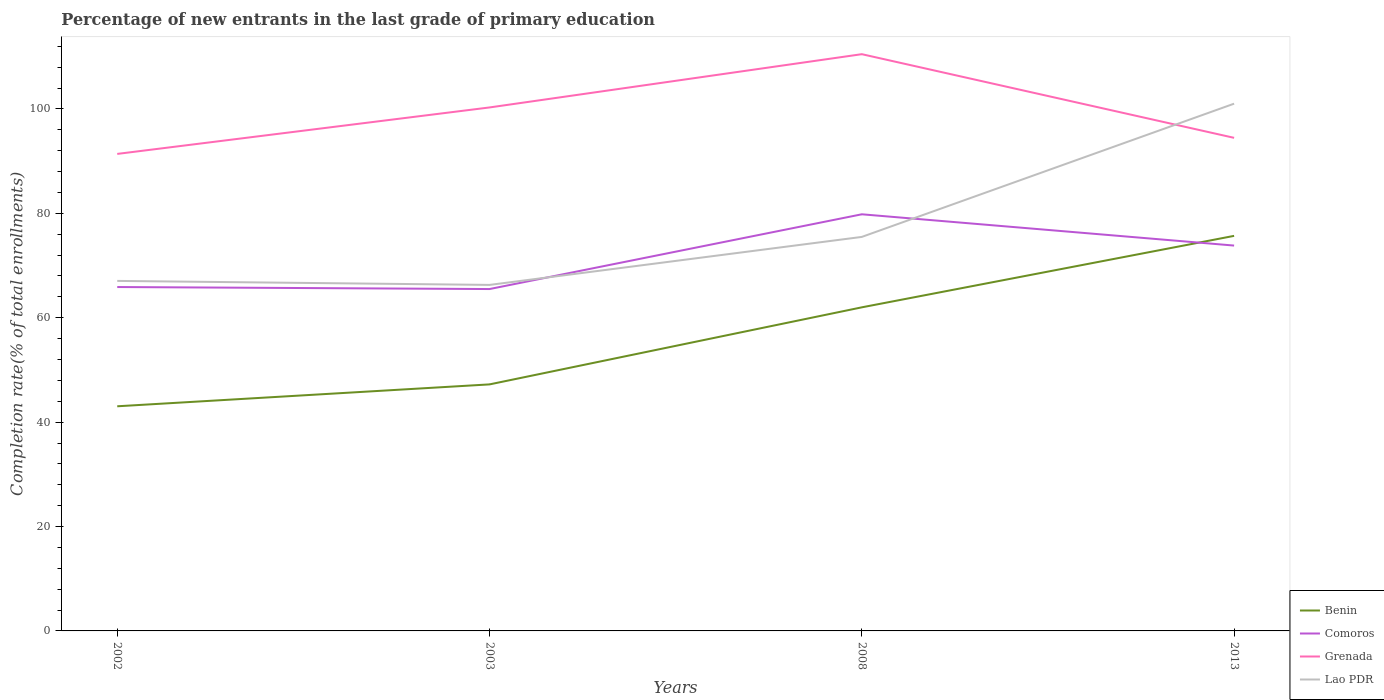How many different coloured lines are there?
Offer a very short reply. 4. Does the line corresponding to Lao PDR intersect with the line corresponding to Comoros?
Offer a terse response. Yes. Across all years, what is the maximum percentage of new entrants in Grenada?
Give a very brief answer. 91.38. In which year was the percentage of new entrants in Lao PDR maximum?
Give a very brief answer. 2003. What is the total percentage of new entrants in Lao PDR in the graph?
Offer a very short reply. -34.72. What is the difference between the highest and the second highest percentage of new entrants in Benin?
Keep it short and to the point. 32.65. How many lines are there?
Offer a very short reply. 4. How many years are there in the graph?
Offer a very short reply. 4. What is the difference between two consecutive major ticks on the Y-axis?
Your answer should be compact. 20. Are the values on the major ticks of Y-axis written in scientific E-notation?
Provide a succinct answer. No. Does the graph contain grids?
Provide a succinct answer. No. Where does the legend appear in the graph?
Give a very brief answer. Bottom right. How many legend labels are there?
Your answer should be very brief. 4. What is the title of the graph?
Provide a short and direct response. Percentage of new entrants in the last grade of primary education. What is the label or title of the X-axis?
Ensure brevity in your answer.  Years. What is the label or title of the Y-axis?
Offer a terse response. Completion rate(% of total enrollments). What is the Completion rate(% of total enrollments) in Benin in 2002?
Offer a terse response. 43.03. What is the Completion rate(% of total enrollments) in Comoros in 2002?
Your answer should be compact. 65.88. What is the Completion rate(% of total enrollments) of Grenada in 2002?
Keep it short and to the point. 91.38. What is the Completion rate(% of total enrollments) in Lao PDR in 2002?
Make the answer very short. 67.05. What is the Completion rate(% of total enrollments) of Benin in 2003?
Offer a very short reply. 47.23. What is the Completion rate(% of total enrollments) of Comoros in 2003?
Offer a terse response. 65.49. What is the Completion rate(% of total enrollments) of Grenada in 2003?
Your answer should be very brief. 100.28. What is the Completion rate(% of total enrollments) of Lao PDR in 2003?
Make the answer very short. 66.29. What is the Completion rate(% of total enrollments) in Benin in 2008?
Offer a terse response. 61.99. What is the Completion rate(% of total enrollments) of Comoros in 2008?
Make the answer very short. 79.82. What is the Completion rate(% of total enrollments) in Grenada in 2008?
Ensure brevity in your answer.  110.49. What is the Completion rate(% of total enrollments) in Lao PDR in 2008?
Your answer should be very brief. 75.48. What is the Completion rate(% of total enrollments) in Benin in 2013?
Make the answer very short. 75.68. What is the Completion rate(% of total enrollments) in Comoros in 2013?
Your answer should be very brief. 73.82. What is the Completion rate(% of total enrollments) of Grenada in 2013?
Make the answer very short. 94.46. What is the Completion rate(% of total enrollments) of Lao PDR in 2013?
Give a very brief answer. 101.01. Across all years, what is the maximum Completion rate(% of total enrollments) of Benin?
Offer a very short reply. 75.68. Across all years, what is the maximum Completion rate(% of total enrollments) in Comoros?
Keep it short and to the point. 79.82. Across all years, what is the maximum Completion rate(% of total enrollments) in Grenada?
Your response must be concise. 110.49. Across all years, what is the maximum Completion rate(% of total enrollments) in Lao PDR?
Your answer should be very brief. 101.01. Across all years, what is the minimum Completion rate(% of total enrollments) of Benin?
Your answer should be very brief. 43.03. Across all years, what is the minimum Completion rate(% of total enrollments) in Comoros?
Provide a short and direct response. 65.49. Across all years, what is the minimum Completion rate(% of total enrollments) in Grenada?
Ensure brevity in your answer.  91.38. Across all years, what is the minimum Completion rate(% of total enrollments) of Lao PDR?
Your answer should be very brief. 66.29. What is the total Completion rate(% of total enrollments) in Benin in the graph?
Offer a very short reply. 227.93. What is the total Completion rate(% of total enrollments) of Comoros in the graph?
Keep it short and to the point. 285.01. What is the total Completion rate(% of total enrollments) in Grenada in the graph?
Your response must be concise. 396.61. What is the total Completion rate(% of total enrollments) of Lao PDR in the graph?
Offer a terse response. 309.82. What is the difference between the Completion rate(% of total enrollments) of Benin in 2002 and that in 2003?
Your response must be concise. -4.19. What is the difference between the Completion rate(% of total enrollments) of Comoros in 2002 and that in 2003?
Offer a very short reply. 0.39. What is the difference between the Completion rate(% of total enrollments) in Grenada in 2002 and that in 2003?
Provide a short and direct response. -8.9. What is the difference between the Completion rate(% of total enrollments) in Lao PDR in 2002 and that in 2003?
Your answer should be very brief. 0.77. What is the difference between the Completion rate(% of total enrollments) of Benin in 2002 and that in 2008?
Your response must be concise. -18.96. What is the difference between the Completion rate(% of total enrollments) of Comoros in 2002 and that in 2008?
Your answer should be compact. -13.94. What is the difference between the Completion rate(% of total enrollments) of Grenada in 2002 and that in 2008?
Offer a terse response. -19.11. What is the difference between the Completion rate(% of total enrollments) in Lao PDR in 2002 and that in 2008?
Your answer should be compact. -8.43. What is the difference between the Completion rate(% of total enrollments) of Benin in 2002 and that in 2013?
Your answer should be very brief. -32.65. What is the difference between the Completion rate(% of total enrollments) in Comoros in 2002 and that in 2013?
Provide a short and direct response. -7.94. What is the difference between the Completion rate(% of total enrollments) in Grenada in 2002 and that in 2013?
Your answer should be compact. -3.08. What is the difference between the Completion rate(% of total enrollments) in Lao PDR in 2002 and that in 2013?
Provide a succinct answer. -33.95. What is the difference between the Completion rate(% of total enrollments) of Benin in 2003 and that in 2008?
Your response must be concise. -14.76. What is the difference between the Completion rate(% of total enrollments) in Comoros in 2003 and that in 2008?
Give a very brief answer. -14.32. What is the difference between the Completion rate(% of total enrollments) in Grenada in 2003 and that in 2008?
Offer a very short reply. -10.21. What is the difference between the Completion rate(% of total enrollments) in Lao PDR in 2003 and that in 2008?
Your response must be concise. -9.2. What is the difference between the Completion rate(% of total enrollments) of Benin in 2003 and that in 2013?
Ensure brevity in your answer.  -28.45. What is the difference between the Completion rate(% of total enrollments) in Comoros in 2003 and that in 2013?
Make the answer very short. -8.33. What is the difference between the Completion rate(% of total enrollments) of Grenada in 2003 and that in 2013?
Give a very brief answer. 5.82. What is the difference between the Completion rate(% of total enrollments) of Lao PDR in 2003 and that in 2013?
Provide a short and direct response. -34.72. What is the difference between the Completion rate(% of total enrollments) in Benin in 2008 and that in 2013?
Offer a very short reply. -13.69. What is the difference between the Completion rate(% of total enrollments) of Comoros in 2008 and that in 2013?
Your answer should be compact. 5.99. What is the difference between the Completion rate(% of total enrollments) in Grenada in 2008 and that in 2013?
Ensure brevity in your answer.  16.03. What is the difference between the Completion rate(% of total enrollments) in Lao PDR in 2008 and that in 2013?
Your answer should be very brief. -25.52. What is the difference between the Completion rate(% of total enrollments) of Benin in 2002 and the Completion rate(% of total enrollments) of Comoros in 2003?
Make the answer very short. -22.46. What is the difference between the Completion rate(% of total enrollments) of Benin in 2002 and the Completion rate(% of total enrollments) of Grenada in 2003?
Ensure brevity in your answer.  -57.25. What is the difference between the Completion rate(% of total enrollments) in Benin in 2002 and the Completion rate(% of total enrollments) in Lao PDR in 2003?
Offer a very short reply. -23.25. What is the difference between the Completion rate(% of total enrollments) of Comoros in 2002 and the Completion rate(% of total enrollments) of Grenada in 2003?
Give a very brief answer. -34.4. What is the difference between the Completion rate(% of total enrollments) of Comoros in 2002 and the Completion rate(% of total enrollments) of Lao PDR in 2003?
Give a very brief answer. -0.41. What is the difference between the Completion rate(% of total enrollments) in Grenada in 2002 and the Completion rate(% of total enrollments) in Lao PDR in 2003?
Provide a short and direct response. 25.1. What is the difference between the Completion rate(% of total enrollments) in Benin in 2002 and the Completion rate(% of total enrollments) in Comoros in 2008?
Offer a terse response. -36.78. What is the difference between the Completion rate(% of total enrollments) in Benin in 2002 and the Completion rate(% of total enrollments) in Grenada in 2008?
Your answer should be compact. -67.45. What is the difference between the Completion rate(% of total enrollments) in Benin in 2002 and the Completion rate(% of total enrollments) in Lao PDR in 2008?
Provide a short and direct response. -32.45. What is the difference between the Completion rate(% of total enrollments) in Comoros in 2002 and the Completion rate(% of total enrollments) in Grenada in 2008?
Provide a short and direct response. -44.61. What is the difference between the Completion rate(% of total enrollments) of Comoros in 2002 and the Completion rate(% of total enrollments) of Lao PDR in 2008?
Provide a succinct answer. -9.6. What is the difference between the Completion rate(% of total enrollments) of Grenada in 2002 and the Completion rate(% of total enrollments) of Lao PDR in 2008?
Your response must be concise. 15.9. What is the difference between the Completion rate(% of total enrollments) of Benin in 2002 and the Completion rate(% of total enrollments) of Comoros in 2013?
Ensure brevity in your answer.  -30.79. What is the difference between the Completion rate(% of total enrollments) in Benin in 2002 and the Completion rate(% of total enrollments) in Grenada in 2013?
Provide a succinct answer. -51.43. What is the difference between the Completion rate(% of total enrollments) of Benin in 2002 and the Completion rate(% of total enrollments) of Lao PDR in 2013?
Your response must be concise. -57.97. What is the difference between the Completion rate(% of total enrollments) of Comoros in 2002 and the Completion rate(% of total enrollments) of Grenada in 2013?
Provide a succinct answer. -28.58. What is the difference between the Completion rate(% of total enrollments) of Comoros in 2002 and the Completion rate(% of total enrollments) of Lao PDR in 2013?
Offer a terse response. -35.13. What is the difference between the Completion rate(% of total enrollments) of Grenada in 2002 and the Completion rate(% of total enrollments) of Lao PDR in 2013?
Your answer should be very brief. -9.62. What is the difference between the Completion rate(% of total enrollments) of Benin in 2003 and the Completion rate(% of total enrollments) of Comoros in 2008?
Offer a very short reply. -32.59. What is the difference between the Completion rate(% of total enrollments) of Benin in 2003 and the Completion rate(% of total enrollments) of Grenada in 2008?
Your answer should be compact. -63.26. What is the difference between the Completion rate(% of total enrollments) in Benin in 2003 and the Completion rate(% of total enrollments) in Lao PDR in 2008?
Keep it short and to the point. -28.25. What is the difference between the Completion rate(% of total enrollments) in Comoros in 2003 and the Completion rate(% of total enrollments) in Grenada in 2008?
Your answer should be very brief. -44.99. What is the difference between the Completion rate(% of total enrollments) in Comoros in 2003 and the Completion rate(% of total enrollments) in Lao PDR in 2008?
Ensure brevity in your answer.  -9.99. What is the difference between the Completion rate(% of total enrollments) in Grenada in 2003 and the Completion rate(% of total enrollments) in Lao PDR in 2008?
Offer a very short reply. 24.8. What is the difference between the Completion rate(% of total enrollments) of Benin in 2003 and the Completion rate(% of total enrollments) of Comoros in 2013?
Your answer should be very brief. -26.59. What is the difference between the Completion rate(% of total enrollments) of Benin in 2003 and the Completion rate(% of total enrollments) of Grenada in 2013?
Offer a very short reply. -47.23. What is the difference between the Completion rate(% of total enrollments) of Benin in 2003 and the Completion rate(% of total enrollments) of Lao PDR in 2013?
Give a very brief answer. -53.78. What is the difference between the Completion rate(% of total enrollments) of Comoros in 2003 and the Completion rate(% of total enrollments) of Grenada in 2013?
Provide a succinct answer. -28.97. What is the difference between the Completion rate(% of total enrollments) of Comoros in 2003 and the Completion rate(% of total enrollments) of Lao PDR in 2013?
Offer a terse response. -35.51. What is the difference between the Completion rate(% of total enrollments) of Grenada in 2003 and the Completion rate(% of total enrollments) of Lao PDR in 2013?
Provide a short and direct response. -0.72. What is the difference between the Completion rate(% of total enrollments) in Benin in 2008 and the Completion rate(% of total enrollments) in Comoros in 2013?
Your response must be concise. -11.83. What is the difference between the Completion rate(% of total enrollments) of Benin in 2008 and the Completion rate(% of total enrollments) of Grenada in 2013?
Offer a very short reply. -32.47. What is the difference between the Completion rate(% of total enrollments) in Benin in 2008 and the Completion rate(% of total enrollments) in Lao PDR in 2013?
Ensure brevity in your answer.  -39.02. What is the difference between the Completion rate(% of total enrollments) of Comoros in 2008 and the Completion rate(% of total enrollments) of Grenada in 2013?
Your answer should be very brief. -14.64. What is the difference between the Completion rate(% of total enrollments) of Comoros in 2008 and the Completion rate(% of total enrollments) of Lao PDR in 2013?
Provide a succinct answer. -21.19. What is the difference between the Completion rate(% of total enrollments) of Grenada in 2008 and the Completion rate(% of total enrollments) of Lao PDR in 2013?
Provide a succinct answer. 9.48. What is the average Completion rate(% of total enrollments) in Benin per year?
Provide a succinct answer. 56.98. What is the average Completion rate(% of total enrollments) of Comoros per year?
Provide a succinct answer. 71.25. What is the average Completion rate(% of total enrollments) of Grenada per year?
Your response must be concise. 99.15. What is the average Completion rate(% of total enrollments) in Lao PDR per year?
Offer a very short reply. 77.46. In the year 2002, what is the difference between the Completion rate(% of total enrollments) in Benin and Completion rate(% of total enrollments) in Comoros?
Make the answer very short. -22.85. In the year 2002, what is the difference between the Completion rate(% of total enrollments) of Benin and Completion rate(% of total enrollments) of Grenada?
Your answer should be compact. -48.35. In the year 2002, what is the difference between the Completion rate(% of total enrollments) in Benin and Completion rate(% of total enrollments) in Lao PDR?
Offer a terse response. -24.02. In the year 2002, what is the difference between the Completion rate(% of total enrollments) of Comoros and Completion rate(% of total enrollments) of Grenada?
Your answer should be compact. -25.5. In the year 2002, what is the difference between the Completion rate(% of total enrollments) of Comoros and Completion rate(% of total enrollments) of Lao PDR?
Offer a very short reply. -1.17. In the year 2002, what is the difference between the Completion rate(% of total enrollments) of Grenada and Completion rate(% of total enrollments) of Lao PDR?
Your answer should be very brief. 24.33. In the year 2003, what is the difference between the Completion rate(% of total enrollments) in Benin and Completion rate(% of total enrollments) in Comoros?
Offer a very short reply. -18.27. In the year 2003, what is the difference between the Completion rate(% of total enrollments) of Benin and Completion rate(% of total enrollments) of Grenada?
Ensure brevity in your answer.  -53.05. In the year 2003, what is the difference between the Completion rate(% of total enrollments) in Benin and Completion rate(% of total enrollments) in Lao PDR?
Provide a short and direct response. -19.06. In the year 2003, what is the difference between the Completion rate(% of total enrollments) in Comoros and Completion rate(% of total enrollments) in Grenada?
Provide a succinct answer. -34.79. In the year 2003, what is the difference between the Completion rate(% of total enrollments) of Comoros and Completion rate(% of total enrollments) of Lao PDR?
Offer a very short reply. -0.79. In the year 2003, what is the difference between the Completion rate(% of total enrollments) in Grenada and Completion rate(% of total enrollments) in Lao PDR?
Offer a very short reply. 34. In the year 2008, what is the difference between the Completion rate(% of total enrollments) of Benin and Completion rate(% of total enrollments) of Comoros?
Offer a very short reply. -17.83. In the year 2008, what is the difference between the Completion rate(% of total enrollments) in Benin and Completion rate(% of total enrollments) in Grenada?
Ensure brevity in your answer.  -48.5. In the year 2008, what is the difference between the Completion rate(% of total enrollments) in Benin and Completion rate(% of total enrollments) in Lao PDR?
Your answer should be compact. -13.49. In the year 2008, what is the difference between the Completion rate(% of total enrollments) of Comoros and Completion rate(% of total enrollments) of Grenada?
Your answer should be compact. -30.67. In the year 2008, what is the difference between the Completion rate(% of total enrollments) in Comoros and Completion rate(% of total enrollments) in Lao PDR?
Your answer should be very brief. 4.33. In the year 2008, what is the difference between the Completion rate(% of total enrollments) of Grenada and Completion rate(% of total enrollments) of Lao PDR?
Make the answer very short. 35.01. In the year 2013, what is the difference between the Completion rate(% of total enrollments) in Benin and Completion rate(% of total enrollments) in Comoros?
Ensure brevity in your answer.  1.86. In the year 2013, what is the difference between the Completion rate(% of total enrollments) of Benin and Completion rate(% of total enrollments) of Grenada?
Offer a terse response. -18.78. In the year 2013, what is the difference between the Completion rate(% of total enrollments) in Benin and Completion rate(% of total enrollments) in Lao PDR?
Offer a very short reply. -25.32. In the year 2013, what is the difference between the Completion rate(% of total enrollments) of Comoros and Completion rate(% of total enrollments) of Grenada?
Offer a terse response. -20.64. In the year 2013, what is the difference between the Completion rate(% of total enrollments) of Comoros and Completion rate(% of total enrollments) of Lao PDR?
Your response must be concise. -27.18. In the year 2013, what is the difference between the Completion rate(% of total enrollments) in Grenada and Completion rate(% of total enrollments) in Lao PDR?
Provide a short and direct response. -6.55. What is the ratio of the Completion rate(% of total enrollments) of Benin in 2002 to that in 2003?
Provide a succinct answer. 0.91. What is the ratio of the Completion rate(% of total enrollments) in Comoros in 2002 to that in 2003?
Ensure brevity in your answer.  1.01. What is the ratio of the Completion rate(% of total enrollments) in Grenada in 2002 to that in 2003?
Offer a terse response. 0.91. What is the ratio of the Completion rate(% of total enrollments) of Lao PDR in 2002 to that in 2003?
Your response must be concise. 1.01. What is the ratio of the Completion rate(% of total enrollments) in Benin in 2002 to that in 2008?
Offer a terse response. 0.69. What is the ratio of the Completion rate(% of total enrollments) in Comoros in 2002 to that in 2008?
Ensure brevity in your answer.  0.83. What is the ratio of the Completion rate(% of total enrollments) in Grenada in 2002 to that in 2008?
Your response must be concise. 0.83. What is the ratio of the Completion rate(% of total enrollments) of Lao PDR in 2002 to that in 2008?
Offer a terse response. 0.89. What is the ratio of the Completion rate(% of total enrollments) of Benin in 2002 to that in 2013?
Offer a terse response. 0.57. What is the ratio of the Completion rate(% of total enrollments) of Comoros in 2002 to that in 2013?
Your answer should be very brief. 0.89. What is the ratio of the Completion rate(% of total enrollments) in Grenada in 2002 to that in 2013?
Ensure brevity in your answer.  0.97. What is the ratio of the Completion rate(% of total enrollments) in Lao PDR in 2002 to that in 2013?
Keep it short and to the point. 0.66. What is the ratio of the Completion rate(% of total enrollments) of Benin in 2003 to that in 2008?
Ensure brevity in your answer.  0.76. What is the ratio of the Completion rate(% of total enrollments) in Comoros in 2003 to that in 2008?
Provide a succinct answer. 0.82. What is the ratio of the Completion rate(% of total enrollments) of Grenada in 2003 to that in 2008?
Provide a short and direct response. 0.91. What is the ratio of the Completion rate(% of total enrollments) in Lao PDR in 2003 to that in 2008?
Give a very brief answer. 0.88. What is the ratio of the Completion rate(% of total enrollments) of Benin in 2003 to that in 2013?
Make the answer very short. 0.62. What is the ratio of the Completion rate(% of total enrollments) in Comoros in 2003 to that in 2013?
Keep it short and to the point. 0.89. What is the ratio of the Completion rate(% of total enrollments) in Grenada in 2003 to that in 2013?
Your response must be concise. 1.06. What is the ratio of the Completion rate(% of total enrollments) in Lao PDR in 2003 to that in 2013?
Make the answer very short. 0.66. What is the ratio of the Completion rate(% of total enrollments) of Benin in 2008 to that in 2013?
Keep it short and to the point. 0.82. What is the ratio of the Completion rate(% of total enrollments) in Comoros in 2008 to that in 2013?
Your answer should be compact. 1.08. What is the ratio of the Completion rate(% of total enrollments) in Grenada in 2008 to that in 2013?
Offer a terse response. 1.17. What is the ratio of the Completion rate(% of total enrollments) of Lao PDR in 2008 to that in 2013?
Offer a terse response. 0.75. What is the difference between the highest and the second highest Completion rate(% of total enrollments) of Benin?
Your answer should be very brief. 13.69. What is the difference between the highest and the second highest Completion rate(% of total enrollments) of Comoros?
Make the answer very short. 5.99. What is the difference between the highest and the second highest Completion rate(% of total enrollments) in Grenada?
Make the answer very short. 10.21. What is the difference between the highest and the second highest Completion rate(% of total enrollments) of Lao PDR?
Your answer should be compact. 25.52. What is the difference between the highest and the lowest Completion rate(% of total enrollments) of Benin?
Give a very brief answer. 32.65. What is the difference between the highest and the lowest Completion rate(% of total enrollments) of Comoros?
Your response must be concise. 14.32. What is the difference between the highest and the lowest Completion rate(% of total enrollments) in Grenada?
Give a very brief answer. 19.11. What is the difference between the highest and the lowest Completion rate(% of total enrollments) of Lao PDR?
Ensure brevity in your answer.  34.72. 